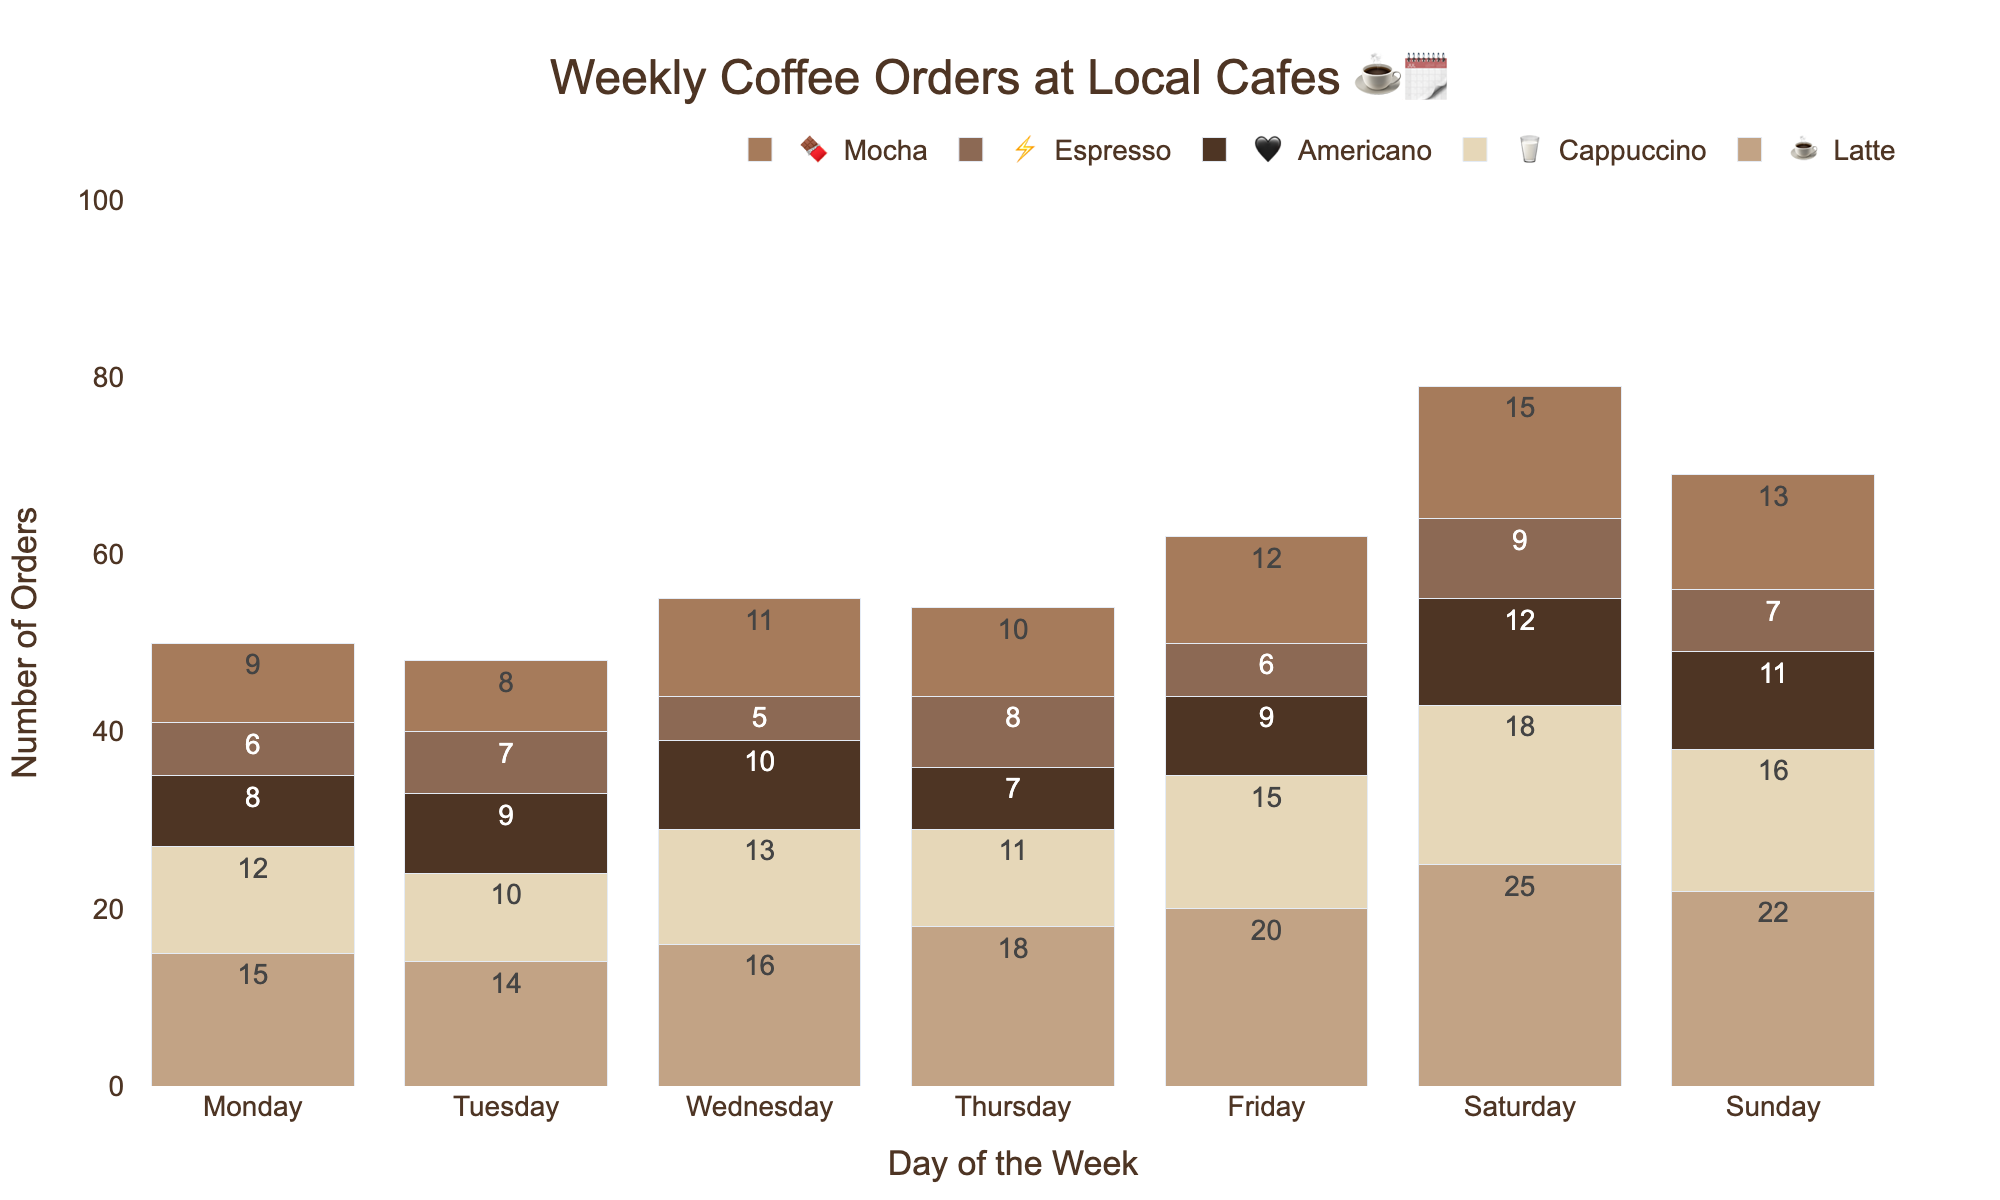What's the most popular coffee drink on Saturday? To find the most popular coffee drink on Saturday, look at the Saturday column and compare the order numbers for each drink. Latte has the highest number of orders, which is 25.
Answer: Latte Which day has the highest total number of coffee orders? Sum up the orders for each day and compare the totals. Saturday has the highest total with (25+18+12+9+15)=79 orders.
Answer: Saturday How many lattes were ordered more on Friday compared to Monday? Subtract Monday's latte orders from Friday's latte orders: (20 - 15) = 5 more lattes were ordered on Friday.
Answer: 5 What's the least popular drink on Tuesday? To determine the least popular drink on Tuesday, check the Tuesday column and identify the drink with the smallest number. Espresso has the lowest order number, which is 7.
Answer: Espresso Which drink saw the most orders increase from Wednesday to Thursday? Subtract Wednesday's order number from Thursday's for each drink and compare. Latte had the highest increase from 16 to 18, an increase of 2.
Answer: Latte Are there more mochas ordered on Sunday than on Friday? Compare the number of mochas ordered on Sunday (13) to that on Friday (12).
Answer: Yes What's the total number of espressos sold over the weekend (Saturday and Sunday)? Add the number of espressos ordered on Saturday (9) to Sunday (7) for the total: (9 + 7) = 16.
Answer: 16 On which day were the fewest total coffee orders placed? Calculate the total orders for each day and compare. Wednesday has the fewest total orders: (16+13+10+5+11)=55.
Answer: Wednesday Which coffee drink had its highest number of orders on Friday? Check Friday's column and compare the order numbers for each drink. Mocha had the highest number of orders on Friday with 12.
Answer: Mocha What's the total number of lattes ordered from Monday to Sunday? Sum the latte orders for each day: (15+14+16+18+20+25+22) = 130.
Answer: 130 